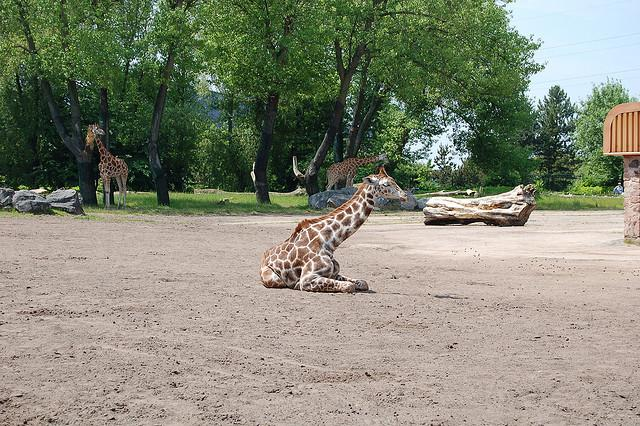What us the giraffe in the foreground sitting on? dirt 